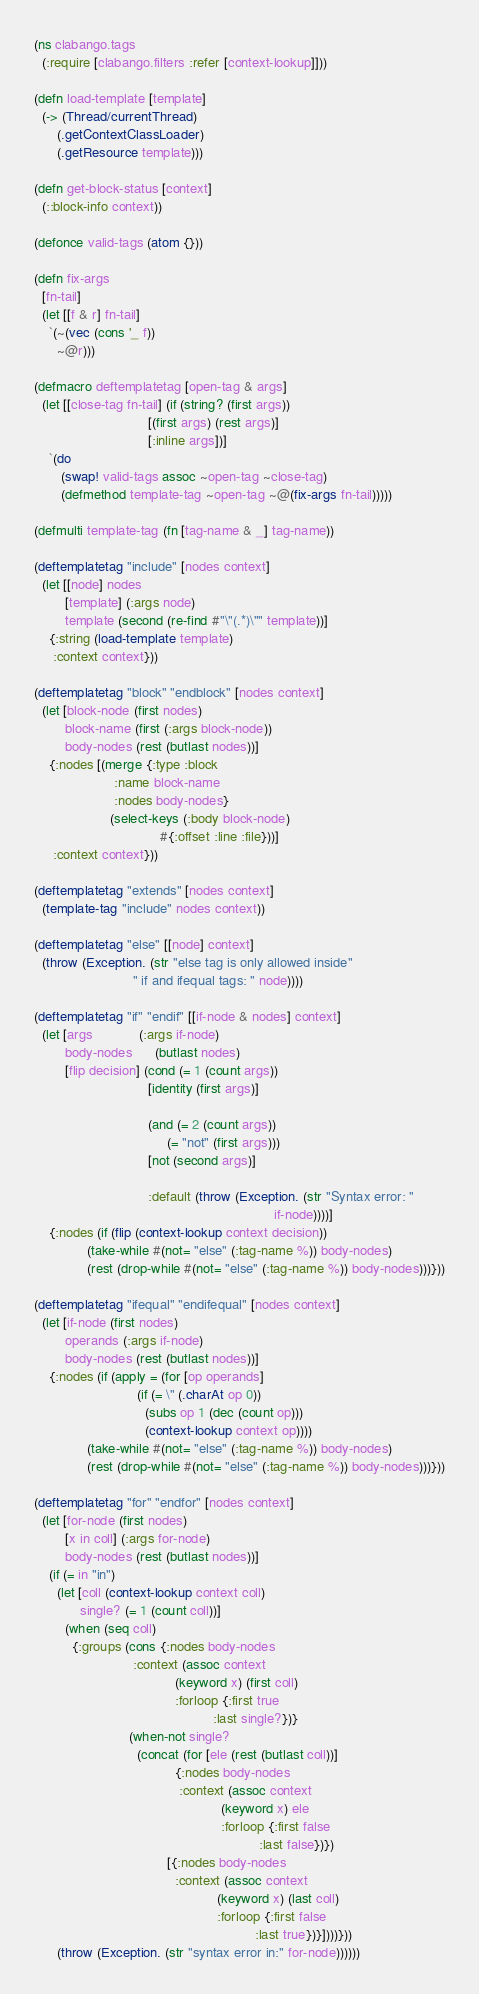<code> <loc_0><loc_0><loc_500><loc_500><_Clojure_>(ns clabango.tags
  (:require [clabango.filters :refer [context-lookup]]))

(defn load-template [template]
  (-> (Thread/currentThread)
      (.getContextClassLoader)
      (.getResource template)))

(defn get-block-status [context]
  (::block-info context))

(defonce valid-tags (atom {}))

(defn fix-args
  [fn-tail]
  (let [[f & r] fn-tail]
    `(~(vec (cons '_ f))
      ~@r)))

(defmacro deftemplatetag [open-tag & args]
  (let [[close-tag fn-tail] (if (string? (first args))
                              [(first args) (rest args)]
                              [:inline args])]
    `(do
       (swap! valid-tags assoc ~open-tag ~close-tag)
       (defmethod template-tag ~open-tag ~@(fix-args fn-tail)))))

(defmulti template-tag (fn [tag-name & _] tag-name))

(deftemplatetag "include" [nodes context]
  (let [[node] nodes
        [template] (:args node)
        template (second (re-find #"\"(.*)\"" template))]
    {:string (load-template template)
     :context context}))

(deftemplatetag "block" "endblock" [nodes context]
  (let [block-node (first nodes)
        block-name (first (:args block-node))
        body-nodes (rest (butlast nodes))]
    {:nodes [(merge {:type :block
                     :name block-name
                     :nodes body-nodes}
                    (select-keys (:body block-node)
                                 #{:offset :line :file}))]
     :context context}))

(deftemplatetag "extends" [nodes context]
  (template-tag "include" nodes context))

(deftemplatetag "else" [[node] context]
  (throw (Exception. (str "else tag is only allowed inside"
                          " if and ifequal tags: " node))))

(deftemplatetag "if" "endif" [[if-node & nodes] context]
  (let [args            (:args if-node)
        body-nodes      (butlast nodes)
        [flip decision] (cond (= 1 (count args))
                              [identity (first args)]

                              (and (= 2 (count args))
                                   (= "not" (first args)))
                              [not (second args)]

                              :default (throw (Exception. (str "Syntax error: "
                                                               if-node))))]
    {:nodes (if (flip (context-lookup context decision))
              (take-while #(not= "else" (:tag-name %)) body-nodes)
              (rest (drop-while #(not= "else" (:tag-name %)) body-nodes)))}))

(deftemplatetag "ifequal" "endifequal" [nodes context]
  (let [if-node (first nodes)
        operands (:args if-node)
        body-nodes (rest (butlast nodes))]
    {:nodes (if (apply = (for [op operands]
                           (if (= \" (.charAt op 0))
                             (subs op 1 (dec (count op)))
                             (context-lookup context op))))
              (take-while #(not= "else" (:tag-name %)) body-nodes)
              (rest (drop-while #(not= "else" (:tag-name %)) body-nodes)))}))

(deftemplatetag "for" "endfor" [nodes context]
  (let [for-node (first nodes)
        [x in coll] (:args for-node)
        body-nodes (rest (butlast nodes))]
    (if (= in "in")
      (let [coll (context-lookup context coll)
            single? (= 1 (count coll))]
        (when (seq coll)
          {:groups (cons {:nodes body-nodes
                          :context (assoc context
                                     (keyword x) (first coll)
                                     :forloop {:first true
                                               :last single?})}
                         (when-not single?
                           (concat (for [ele (rest (butlast coll))]
                                     {:nodes body-nodes
                                      :context (assoc context
                                                 (keyword x) ele
                                                 :forloop {:first false
                                                           :last false})})
                                   [{:nodes body-nodes
                                     :context (assoc context
                                                (keyword x) (last coll)
                                                :forloop {:first false
                                                          :last true})}])))}))
      (throw (Exception. (str "syntax error in:" for-node))))))
</code> 